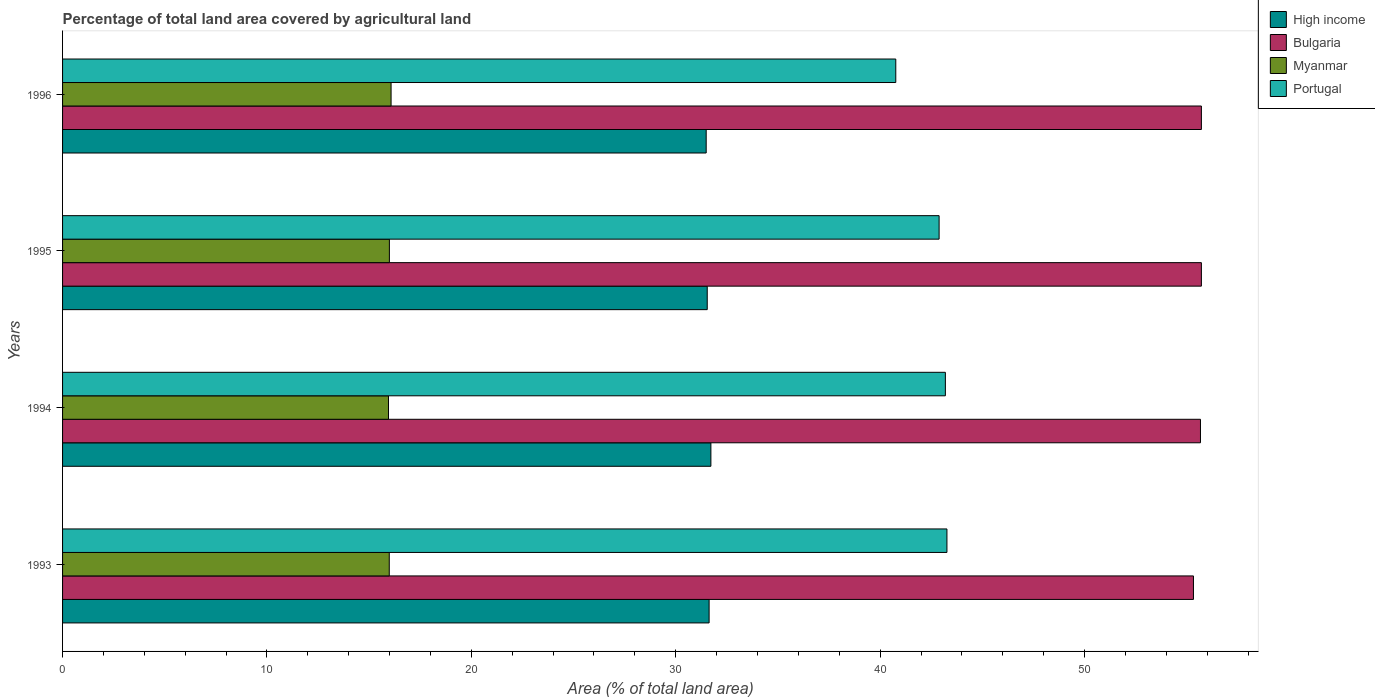How many groups of bars are there?
Give a very brief answer. 4. Are the number of bars per tick equal to the number of legend labels?
Provide a short and direct response. Yes. How many bars are there on the 1st tick from the top?
Your answer should be compact. 4. How many bars are there on the 3rd tick from the bottom?
Give a very brief answer. 4. What is the percentage of agricultural land in Myanmar in 1996?
Offer a very short reply. 16.07. Across all years, what is the maximum percentage of agricultural land in Myanmar?
Make the answer very short. 16.07. Across all years, what is the minimum percentage of agricultural land in Myanmar?
Your response must be concise. 15.95. In which year was the percentage of agricultural land in Bulgaria maximum?
Provide a succinct answer. 1995. What is the total percentage of agricultural land in High income in the graph?
Make the answer very short. 126.38. What is the difference between the percentage of agricultural land in Portugal in 1995 and that in 1996?
Your answer should be compact. 2.12. What is the difference between the percentage of agricultural land in High income in 1996 and the percentage of agricultural land in Myanmar in 1995?
Provide a succinct answer. 15.5. What is the average percentage of agricultural land in Myanmar per year?
Your answer should be very brief. 16. In the year 1993, what is the difference between the percentage of agricultural land in Myanmar and percentage of agricultural land in Portugal?
Provide a short and direct response. -27.28. What is the ratio of the percentage of agricultural land in Myanmar in 1994 to that in 1996?
Provide a short and direct response. 0.99. Is the percentage of agricultural land in Myanmar in 1994 less than that in 1995?
Ensure brevity in your answer.  Yes. What is the difference between the highest and the second highest percentage of agricultural land in Myanmar?
Ensure brevity in your answer.  0.08. What is the difference between the highest and the lowest percentage of agricultural land in Portugal?
Ensure brevity in your answer.  2.5. In how many years, is the percentage of agricultural land in Bulgaria greater than the average percentage of agricultural land in Bulgaria taken over all years?
Your response must be concise. 3. What does the 2nd bar from the bottom in 1995 represents?
Your response must be concise. Bulgaria. Is it the case that in every year, the sum of the percentage of agricultural land in Portugal and percentage of agricultural land in Myanmar is greater than the percentage of agricultural land in Bulgaria?
Keep it short and to the point. Yes. How many bars are there?
Ensure brevity in your answer.  16. Are all the bars in the graph horizontal?
Make the answer very short. Yes. Does the graph contain any zero values?
Provide a short and direct response. No. How are the legend labels stacked?
Give a very brief answer. Vertical. What is the title of the graph?
Your response must be concise. Percentage of total land area covered by agricultural land. What is the label or title of the X-axis?
Your answer should be compact. Area (% of total land area). What is the Area (% of total land area) of High income in 1993?
Make the answer very short. 31.63. What is the Area (% of total land area) in Bulgaria in 1993?
Provide a succinct answer. 55.33. What is the Area (% of total land area) of Myanmar in 1993?
Provide a succinct answer. 15.98. What is the Area (% of total land area) in Portugal in 1993?
Your answer should be very brief. 43.27. What is the Area (% of total land area) in High income in 1994?
Make the answer very short. 31.72. What is the Area (% of total land area) of Bulgaria in 1994?
Keep it short and to the point. 55.67. What is the Area (% of total land area) of Myanmar in 1994?
Offer a terse response. 15.95. What is the Area (% of total land area) in Portugal in 1994?
Offer a terse response. 43.19. What is the Area (% of total land area) in High income in 1995?
Make the answer very short. 31.54. What is the Area (% of total land area) in Bulgaria in 1995?
Your answer should be compact. 55.72. What is the Area (% of total land area) in Myanmar in 1995?
Offer a terse response. 15.99. What is the Area (% of total land area) of Portugal in 1995?
Give a very brief answer. 42.89. What is the Area (% of total land area) in High income in 1996?
Your response must be concise. 31.49. What is the Area (% of total land area) in Bulgaria in 1996?
Offer a very short reply. 55.72. What is the Area (% of total land area) of Myanmar in 1996?
Ensure brevity in your answer.  16.07. What is the Area (% of total land area) in Portugal in 1996?
Provide a succinct answer. 40.77. Across all years, what is the maximum Area (% of total land area) in High income?
Offer a very short reply. 31.72. Across all years, what is the maximum Area (% of total land area) of Bulgaria?
Your answer should be compact. 55.72. Across all years, what is the maximum Area (% of total land area) of Myanmar?
Offer a very short reply. 16.07. Across all years, what is the maximum Area (% of total land area) of Portugal?
Provide a succinct answer. 43.27. Across all years, what is the minimum Area (% of total land area) of High income?
Your response must be concise. 31.49. Across all years, what is the minimum Area (% of total land area) of Bulgaria?
Offer a terse response. 55.33. Across all years, what is the minimum Area (% of total land area) in Myanmar?
Your response must be concise. 15.95. Across all years, what is the minimum Area (% of total land area) of Portugal?
Ensure brevity in your answer.  40.77. What is the total Area (% of total land area) of High income in the graph?
Provide a short and direct response. 126.38. What is the total Area (% of total land area) in Bulgaria in the graph?
Offer a very short reply. 222.44. What is the total Area (% of total land area) of Myanmar in the graph?
Your answer should be compact. 63.99. What is the total Area (% of total land area) of Portugal in the graph?
Provide a short and direct response. 170.11. What is the difference between the Area (% of total land area) in High income in 1993 and that in 1994?
Make the answer very short. -0.09. What is the difference between the Area (% of total land area) in Bulgaria in 1993 and that in 1994?
Offer a terse response. -0.34. What is the difference between the Area (% of total land area) in Myanmar in 1993 and that in 1994?
Offer a very short reply. 0.04. What is the difference between the Area (% of total land area) of Portugal in 1993 and that in 1994?
Your answer should be compact. 0.08. What is the difference between the Area (% of total land area) in High income in 1993 and that in 1995?
Ensure brevity in your answer.  0.09. What is the difference between the Area (% of total land area) of Bulgaria in 1993 and that in 1995?
Give a very brief answer. -0.39. What is the difference between the Area (% of total land area) in Myanmar in 1993 and that in 1995?
Make the answer very short. -0.01. What is the difference between the Area (% of total land area) of Portugal in 1993 and that in 1995?
Keep it short and to the point. 0.38. What is the difference between the Area (% of total land area) in High income in 1993 and that in 1996?
Provide a short and direct response. 0.14. What is the difference between the Area (% of total land area) of Bulgaria in 1993 and that in 1996?
Your answer should be compact. -0.39. What is the difference between the Area (% of total land area) in Myanmar in 1993 and that in 1996?
Make the answer very short. -0.09. What is the difference between the Area (% of total land area) of Portugal in 1993 and that in 1996?
Offer a very short reply. 2.5. What is the difference between the Area (% of total land area) in High income in 1994 and that in 1995?
Ensure brevity in your answer.  0.18. What is the difference between the Area (% of total land area) in Bulgaria in 1994 and that in 1995?
Your answer should be compact. -0.05. What is the difference between the Area (% of total land area) in Myanmar in 1994 and that in 1995?
Your answer should be very brief. -0.04. What is the difference between the Area (% of total land area) of Portugal in 1994 and that in 1995?
Ensure brevity in your answer.  0.31. What is the difference between the Area (% of total land area) of High income in 1994 and that in 1996?
Offer a very short reply. 0.23. What is the difference between the Area (% of total land area) in Bulgaria in 1994 and that in 1996?
Keep it short and to the point. -0.05. What is the difference between the Area (% of total land area) in Myanmar in 1994 and that in 1996?
Make the answer very short. -0.13. What is the difference between the Area (% of total land area) of Portugal in 1994 and that in 1996?
Ensure brevity in your answer.  2.43. What is the difference between the Area (% of total land area) of High income in 1995 and that in 1996?
Your answer should be compact. 0.05. What is the difference between the Area (% of total land area) of Bulgaria in 1995 and that in 1996?
Your answer should be compact. 0. What is the difference between the Area (% of total land area) of Myanmar in 1995 and that in 1996?
Your answer should be compact. -0.08. What is the difference between the Area (% of total land area) in Portugal in 1995 and that in 1996?
Provide a succinct answer. 2.12. What is the difference between the Area (% of total land area) in High income in 1993 and the Area (% of total land area) in Bulgaria in 1994?
Ensure brevity in your answer.  -24.04. What is the difference between the Area (% of total land area) of High income in 1993 and the Area (% of total land area) of Myanmar in 1994?
Your answer should be very brief. 15.69. What is the difference between the Area (% of total land area) of High income in 1993 and the Area (% of total land area) of Portugal in 1994?
Your response must be concise. -11.56. What is the difference between the Area (% of total land area) in Bulgaria in 1993 and the Area (% of total land area) in Myanmar in 1994?
Offer a terse response. 39.38. What is the difference between the Area (% of total land area) of Bulgaria in 1993 and the Area (% of total land area) of Portugal in 1994?
Offer a very short reply. 12.14. What is the difference between the Area (% of total land area) of Myanmar in 1993 and the Area (% of total land area) of Portugal in 1994?
Offer a terse response. -27.21. What is the difference between the Area (% of total land area) of High income in 1993 and the Area (% of total land area) of Bulgaria in 1995?
Provide a succinct answer. -24.09. What is the difference between the Area (% of total land area) in High income in 1993 and the Area (% of total land area) in Myanmar in 1995?
Give a very brief answer. 15.64. What is the difference between the Area (% of total land area) of High income in 1993 and the Area (% of total land area) of Portugal in 1995?
Provide a succinct answer. -11.25. What is the difference between the Area (% of total land area) of Bulgaria in 1993 and the Area (% of total land area) of Myanmar in 1995?
Make the answer very short. 39.34. What is the difference between the Area (% of total land area) of Bulgaria in 1993 and the Area (% of total land area) of Portugal in 1995?
Ensure brevity in your answer.  12.44. What is the difference between the Area (% of total land area) in Myanmar in 1993 and the Area (% of total land area) in Portugal in 1995?
Give a very brief answer. -26.9. What is the difference between the Area (% of total land area) of High income in 1993 and the Area (% of total land area) of Bulgaria in 1996?
Your answer should be compact. -24.09. What is the difference between the Area (% of total land area) in High income in 1993 and the Area (% of total land area) in Myanmar in 1996?
Keep it short and to the point. 15.56. What is the difference between the Area (% of total land area) in High income in 1993 and the Area (% of total land area) in Portugal in 1996?
Make the answer very short. -9.13. What is the difference between the Area (% of total land area) of Bulgaria in 1993 and the Area (% of total land area) of Myanmar in 1996?
Your answer should be very brief. 39.26. What is the difference between the Area (% of total land area) of Bulgaria in 1993 and the Area (% of total land area) of Portugal in 1996?
Your answer should be very brief. 14.56. What is the difference between the Area (% of total land area) of Myanmar in 1993 and the Area (% of total land area) of Portugal in 1996?
Ensure brevity in your answer.  -24.78. What is the difference between the Area (% of total land area) of High income in 1994 and the Area (% of total land area) of Bulgaria in 1995?
Provide a succinct answer. -24. What is the difference between the Area (% of total land area) in High income in 1994 and the Area (% of total land area) in Myanmar in 1995?
Make the answer very short. 15.73. What is the difference between the Area (% of total land area) in High income in 1994 and the Area (% of total land area) in Portugal in 1995?
Offer a very short reply. -11.17. What is the difference between the Area (% of total land area) in Bulgaria in 1994 and the Area (% of total land area) in Myanmar in 1995?
Give a very brief answer. 39.68. What is the difference between the Area (% of total land area) in Bulgaria in 1994 and the Area (% of total land area) in Portugal in 1995?
Offer a terse response. 12.79. What is the difference between the Area (% of total land area) in Myanmar in 1994 and the Area (% of total land area) in Portugal in 1995?
Offer a very short reply. -26.94. What is the difference between the Area (% of total land area) in High income in 1994 and the Area (% of total land area) in Bulgaria in 1996?
Give a very brief answer. -24. What is the difference between the Area (% of total land area) of High income in 1994 and the Area (% of total land area) of Myanmar in 1996?
Offer a very short reply. 15.65. What is the difference between the Area (% of total land area) of High income in 1994 and the Area (% of total land area) of Portugal in 1996?
Provide a succinct answer. -9.05. What is the difference between the Area (% of total land area) in Bulgaria in 1994 and the Area (% of total land area) in Myanmar in 1996?
Your answer should be very brief. 39.6. What is the difference between the Area (% of total land area) of Bulgaria in 1994 and the Area (% of total land area) of Portugal in 1996?
Ensure brevity in your answer.  14.91. What is the difference between the Area (% of total land area) of Myanmar in 1994 and the Area (% of total land area) of Portugal in 1996?
Give a very brief answer. -24.82. What is the difference between the Area (% of total land area) in High income in 1995 and the Area (% of total land area) in Bulgaria in 1996?
Ensure brevity in your answer.  -24.18. What is the difference between the Area (% of total land area) of High income in 1995 and the Area (% of total land area) of Myanmar in 1996?
Provide a succinct answer. 15.47. What is the difference between the Area (% of total land area) in High income in 1995 and the Area (% of total land area) in Portugal in 1996?
Offer a terse response. -9.22. What is the difference between the Area (% of total land area) in Bulgaria in 1995 and the Area (% of total land area) in Myanmar in 1996?
Provide a short and direct response. 39.64. What is the difference between the Area (% of total land area) in Bulgaria in 1995 and the Area (% of total land area) in Portugal in 1996?
Your response must be concise. 14.95. What is the difference between the Area (% of total land area) of Myanmar in 1995 and the Area (% of total land area) of Portugal in 1996?
Provide a succinct answer. -24.78. What is the average Area (% of total land area) of High income per year?
Offer a very short reply. 31.6. What is the average Area (% of total land area) of Bulgaria per year?
Offer a very short reply. 55.61. What is the average Area (% of total land area) of Myanmar per year?
Your answer should be very brief. 16. What is the average Area (% of total land area) in Portugal per year?
Your answer should be compact. 42.53. In the year 1993, what is the difference between the Area (% of total land area) of High income and Area (% of total land area) of Bulgaria?
Offer a terse response. -23.7. In the year 1993, what is the difference between the Area (% of total land area) in High income and Area (% of total land area) in Myanmar?
Offer a very short reply. 15.65. In the year 1993, what is the difference between the Area (% of total land area) of High income and Area (% of total land area) of Portugal?
Offer a very short reply. -11.64. In the year 1993, what is the difference between the Area (% of total land area) of Bulgaria and Area (% of total land area) of Myanmar?
Your answer should be very brief. 39.34. In the year 1993, what is the difference between the Area (% of total land area) of Bulgaria and Area (% of total land area) of Portugal?
Offer a terse response. 12.06. In the year 1993, what is the difference between the Area (% of total land area) of Myanmar and Area (% of total land area) of Portugal?
Offer a very short reply. -27.28. In the year 1994, what is the difference between the Area (% of total land area) in High income and Area (% of total land area) in Bulgaria?
Give a very brief answer. -23.95. In the year 1994, what is the difference between the Area (% of total land area) of High income and Area (% of total land area) of Myanmar?
Give a very brief answer. 15.77. In the year 1994, what is the difference between the Area (% of total land area) of High income and Area (% of total land area) of Portugal?
Offer a very short reply. -11.47. In the year 1994, what is the difference between the Area (% of total land area) in Bulgaria and Area (% of total land area) in Myanmar?
Make the answer very short. 39.73. In the year 1994, what is the difference between the Area (% of total land area) in Bulgaria and Area (% of total land area) in Portugal?
Provide a succinct answer. 12.48. In the year 1994, what is the difference between the Area (% of total land area) in Myanmar and Area (% of total land area) in Portugal?
Ensure brevity in your answer.  -27.25. In the year 1995, what is the difference between the Area (% of total land area) in High income and Area (% of total land area) in Bulgaria?
Give a very brief answer. -24.18. In the year 1995, what is the difference between the Area (% of total land area) in High income and Area (% of total land area) in Myanmar?
Your response must be concise. 15.55. In the year 1995, what is the difference between the Area (% of total land area) in High income and Area (% of total land area) in Portugal?
Your answer should be very brief. -11.34. In the year 1995, what is the difference between the Area (% of total land area) in Bulgaria and Area (% of total land area) in Myanmar?
Provide a short and direct response. 39.73. In the year 1995, what is the difference between the Area (% of total land area) in Bulgaria and Area (% of total land area) in Portugal?
Keep it short and to the point. 12.83. In the year 1995, what is the difference between the Area (% of total land area) of Myanmar and Area (% of total land area) of Portugal?
Provide a short and direct response. -26.9. In the year 1996, what is the difference between the Area (% of total land area) of High income and Area (% of total land area) of Bulgaria?
Keep it short and to the point. -24.23. In the year 1996, what is the difference between the Area (% of total land area) in High income and Area (% of total land area) in Myanmar?
Give a very brief answer. 15.42. In the year 1996, what is the difference between the Area (% of total land area) of High income and Area (% of total land area) of Portugal?
Offer a terse response. -9.28. In the year 1996, what is the difference between the Area (% of total land area) of Bulgaria and Area (% of total land area) of Myanmar?
Provide a succinct answer. 39.64. In the year 1996, what is the difference between the Area (% of total land area) of Bulgaria and Area (% of total land area) of Portugal?
Provide a short and direct response. 14.95. In the year 1996, what is the difference between the Area (% of total land area) of Myanmar and Area (% of total land area) of Portugal?
Give a very brief answer. -24.69. What is the ratio of the Area (% of total land area) in High income in 1993 to that in 1994?
Give a very brief answer. 1. What is the ratio of the Area (% of total land area) of Portugal in 1993 to that in 1994?
Ensure brevity in your answer.  1. What is the ratio of the Area (% of total land area) of High income in 1993 to that in 1995?
Your answer should be compact. 1. What is the ratio of the Area (% of total land area) of Bulgaria in 1993 to that in 1995?
Ensure brevity in your answer.  0.99. What is the ratio of the Area (% of total land area) in Portugal in 1993 to that in 1995?
Provide a succinct answer. 1.01. What is the ratio of the Area (% of total land area) of Bulgaria in 1993 to that in 1996?
Ensure brevity in your answer.  0.99. What is the ratio of the Area (% of total land area) in Portugal in 1993 to that in 1996?
Provide a short and direct response. 1.06. What is the ratio of the Area (% of total land area) in High income in 1994 to that in 1995?
Your answer should be very brief. 1.01. What is the ratio of the Area (% of total land area) of Bulgaria in 1994 to that in 1995?
Offer a very short reply. 1. What is the ratio of the Area (% of total land area) in Portugal in 1994 to that in 1995?
Your answer should be very brief. 1.01. What is the ratio of the Area (% of total land area) of High income in 1994 to that in 1996?
Provide a short and direct response. 1.01. What is the ratio of the Area (% of total land area) in Myanmar in 1994 to that in 1996?
Offer a terse response. 0.99. What is the ratio of the Area (% of total land area) of Portugal in 1994 to that in 1996?
Provide a short and direct response. 1.06. What is the ratio of the Area (% of total land area) of Bulgaria in 1995 to that in 1996?
Provide a short and direct response. 1. What is the ratio of the Area (% of total land area) in Myanmar in 1995 to that in 1996?
Offer a very short reply. 0.99. What is the ratio of the Area (% of total land area) in Portugal in 1995 to that in 1996?
Your response must be concise. 1.05. What is the difference between the highest and the second highest Area (% of total land area) of High income?
Offer a very short reply. 0.09. What is the difference between the highest and the second highest Area (% of total land area) of Myanmar?
Ensure brevity in your answer.  0.08. What is the difference between the highest and the second highest Area (% of total land area) in Portugal?
Your answer should be very brief. 0.08. What is the difference between the highest and the lowest Area (% of total land area) of High income?
Ensure brevity in your answer.  0.23. What is the difference between the highest and the lowest Area (% of total land area) in Bulgaria?
Ensure brevity in your answer.  0.39. What is the difference between the highest and the lowest Area (% of total land area) in Myanmar?
Offer a very short reply. 0.13. What is the difference between the highest and the lowest Area (% of total land area) of Portugal?
Your response must be concise. 2.5. 